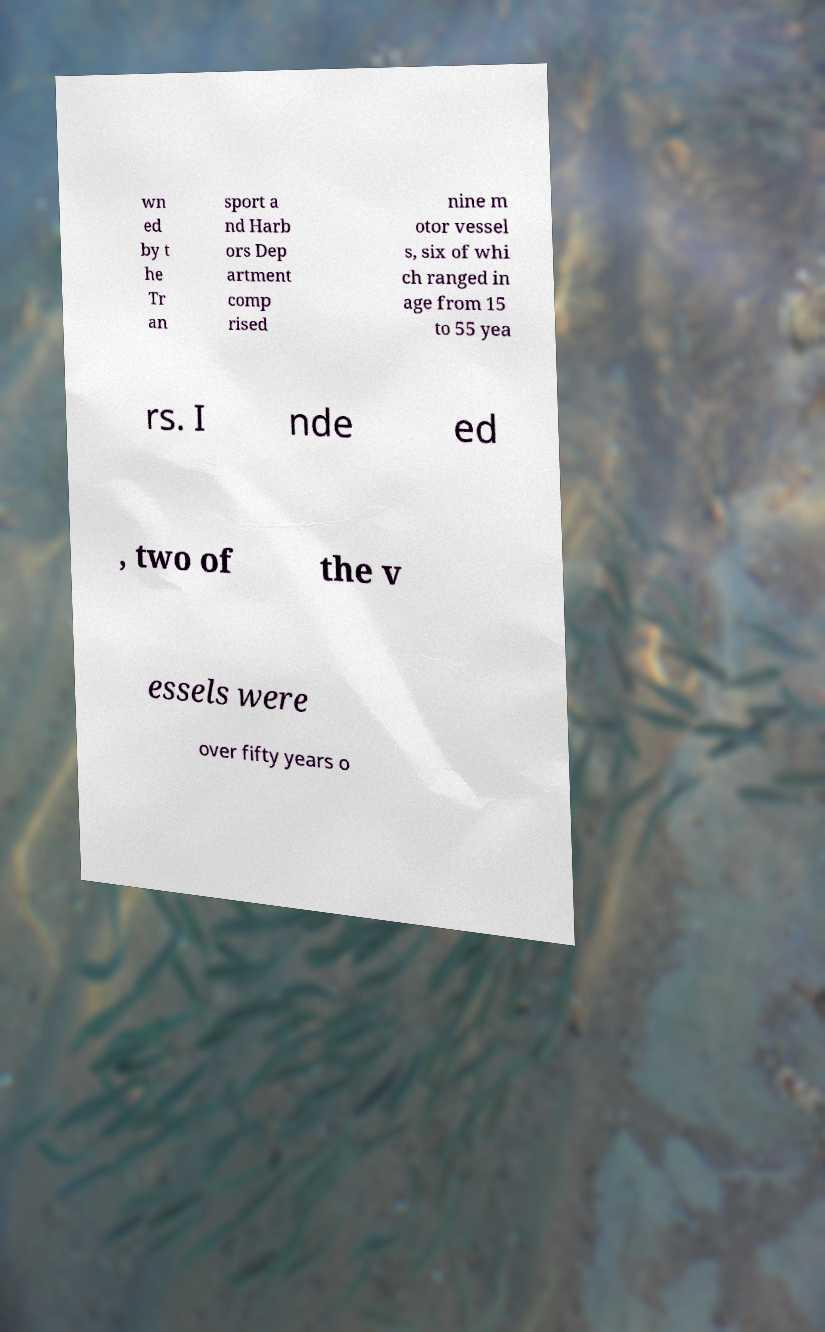For documentation purposes, I need the text within this image transcribed. Could you provide that? wn ed by t he Tr an sport a nd Harb ors Dep artment comp rised nine m otor vessel s, six of whi ch ranged in age from 15 to 55 yea rs. I nde ed , two of the v essels were over fifty years o 